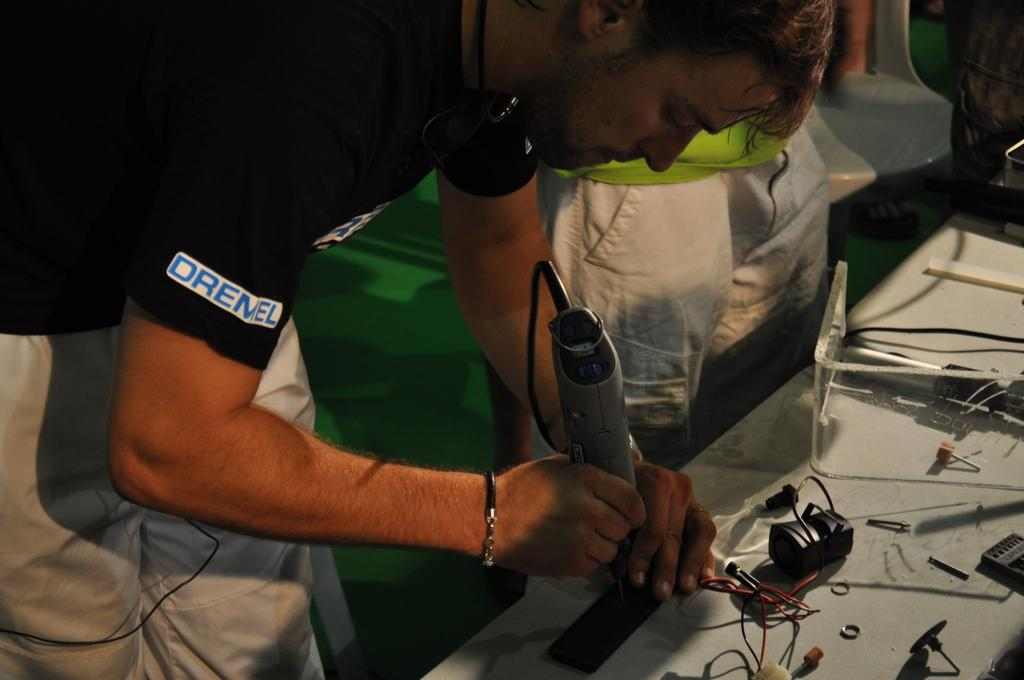Provide a one-sentence caption for the provided image. A man wearing a balck shirt with the word, "Dremel" as he holds a power tool. 